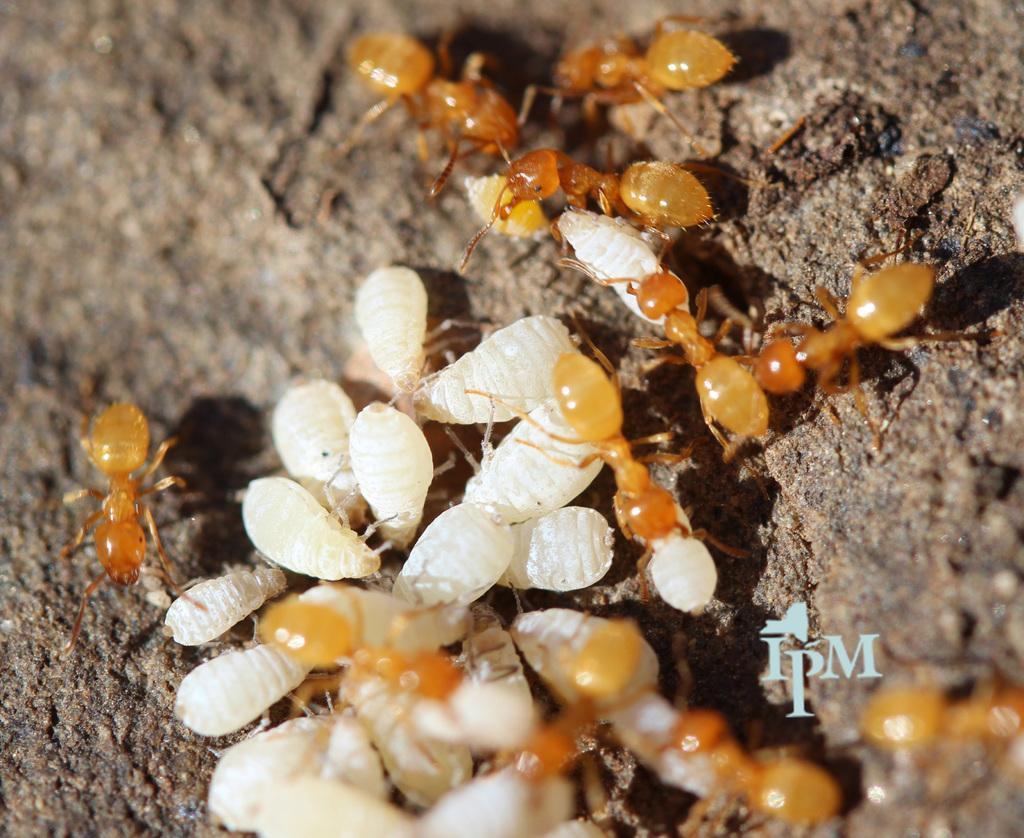What type of living organisms can be seen in the image? Insects can be seen in the image. Is there any text present in the image? Yes, there is some text written on the image. What type of instrument is being played by the fireman in the image? There is no fireman or instrument present in the image. How many apples are visible in the image? There are no apples present in the image. 